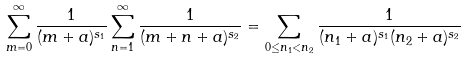Convert formula to latex. <formula><loc_0><loc_0><loc_500><loc_500>\sum _ { m = 0 } ^ { \infty } \frac { 1 } { ( m + a ) ^ { s _ { 1 } } } \sum _ { n = 1 } ^ { \infty } \frac { 1 } { ( m + n + a ) ^ { s _ { 2 } } } = \sum _ { 0 \leq n _ { 1 } < n _ { 2 } } \frac { 1 } { ( n _ { 1 } + a ) ^ { s _ { 1 } } ( n _ { 2 } + a ) ^ { s _ { 2 } } }</formula> 